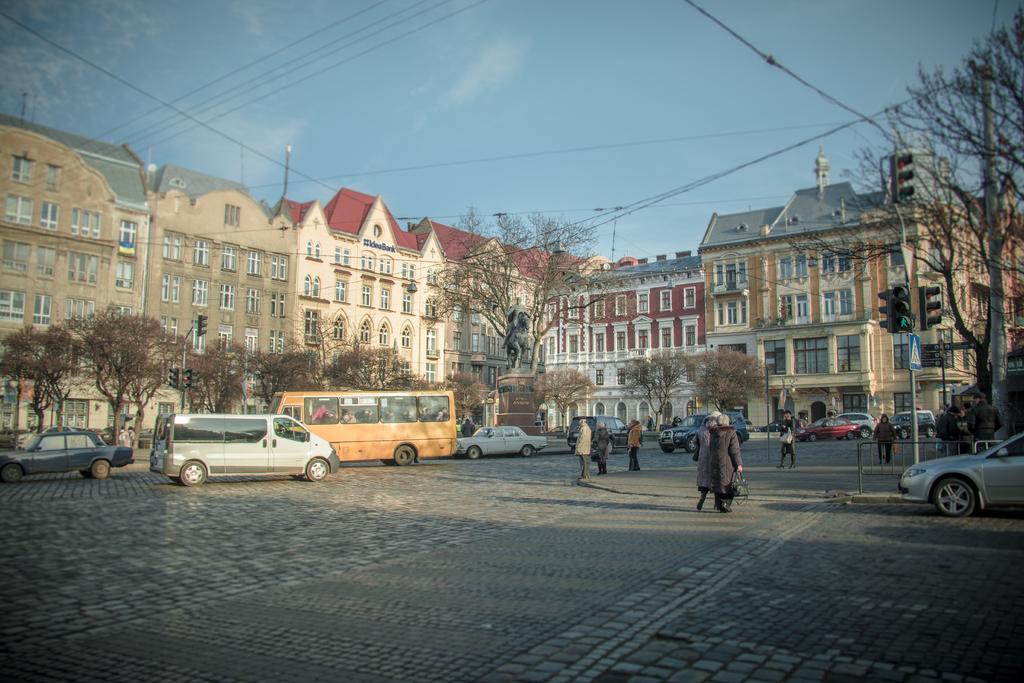In one or two sentences, can you explain what this image depicts? In this picture I can see there are few vehicles moving, there are few people walking, in the backdrop there is a statue, there are trees and there is a building with windows and the sky is clear. 